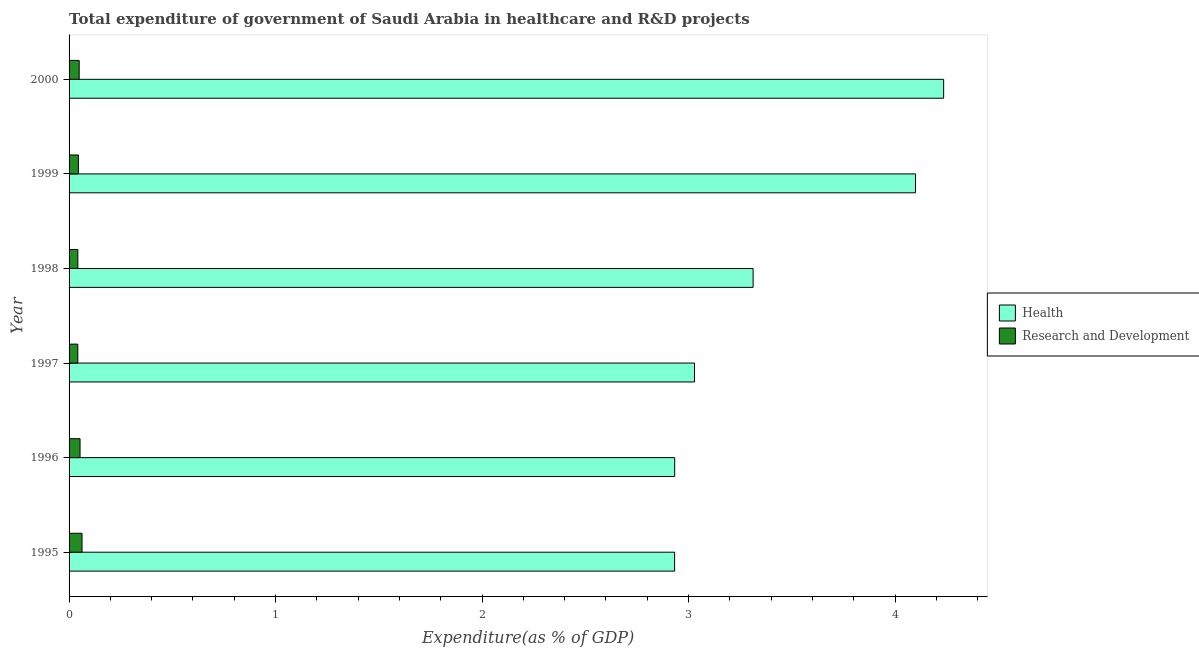How many different coloured bars are there?
Give a very brief answer. 2. How many groups of bars are there?
Give a very brief answer. 6. Are the number of bars per tick equal to the number of legend labels?
Keep it short and to the point. Yes. Are the number of bars on each tick of the Y-axis equal?
Ensure brevity in your answer.  Yes. What is the label of the 3rd group of bars from the top?
Offer a very short reply. 1998. In how many cases, is the number of bars for a given year not equal to the number of legend labels?
Provide a short and direct response. 0. What is the expenditure in r&d in 1998?
Keep it short and to the point. 0.04. Across all years, what is the maximum expenditure in healthcare?
Your response must be concise. 4.24. Across all years, what is the minimum expenditure in healthcare?
Offer a very short reply. 2.93. In which year was the expenditure in r&d maximum?
Your response must be concise. 1995. In which year was the expenditure in healthcare minimum?
Ensure brevity in your answer.  1995. What is the total expenditure in r&d in the graph?
Keep it short and to the point. 0.29. What is the difference between the expenditure in r&d in 1997 and that in 2000?
Provide a succinct answer. -0.01. What is the difference between the expenditure in r&d in 2000 and the expenditure in healthcare in 1997?
Keep it short and to the point. -2.98. What is the average expenditure in healthcare per year?
Keep it short and to the point. 3.42. In the year 1998, what is the difference between the expenditure in healthcare and expenditure in r&d?
Give a very brief answer. 3.27. What is the ratio of the expenditure in healthcare in 1995 to that in 1996?
Your answer should be very brief. 1. Is the difference between the expenditure in healthcare in 1995 and 2000 greater than the difference between the expenditure in r&d in 1995 and 2000?
Your answer should be very brief. No. What is the difference between the highest and the second highest expenditure in healthcare?
Ensure brevity in your answer.  0.14. In how many years, is the expenditure in healthcare greater than the average expenditure in healthcare taken over all years?
Provide a succinct answer. 2. What does the 1st bar from the top in 1996 represents?
Provide a short and direct response. Research and Development. What does the 1st bar from the bottom in 1996 represents?
Provide a short and direct response. Health. How many bars are there?
Keep it short and to the point. 12. Are all the bars in the graph horizontal?
Provide a succinct answer. Yes. Where does the legend appear in the graph?
Offer a terse response. Center right. How are the legend labels stacked?
Offer a very short reply. Vertical. What is the title of the graph?
Your answer should be compact. Total expenditure of government of Saudi Arabia in healthcare and R&D projects. Does "Under-5(female)" appear as one of the legend labels in the graph?
Give a very brief answer. No. What is the label or title of the X-axis?
Give a very brief answer. Expenditure(as % of GDP). What is the label or title of the Y-axis?
Ensure brevity in your answer.  Year. What is the Expenditure(as % of GDP) of Health in 1995?
Your answer should be compact. 2.93. What is the Expenditure(as % of GDP) of Research and Development in 1995?
Provide a succinct answer. 0.06. What is the Expenditure(as % of GDP) in Health in 1996?
Your answer should be very brief. 2.93. What is the Expenditure(as % of GDP) in Research and Development in 1996?
Provide a succinct answer. 0.05. What is the Expenditure(as % of GDP) in Health in 1997?
Your response must be concise. 3.03. What is the Expenditure(as % of GDP) of Research and Development in 1997?
Make the answer very short. 0.04. What is the Expenditure(as % of GDP) of Health in 1998?
Your response must be concise. 3.31. What is the Expenditure(as % of GDP) in Research and Development in 1998?
Offer a terse response. 0.04. What is the Expenditure(as % of GDP) in Health in 1999?
Your response must be concise. 4.1. What is the Expenditure(as % of GDP) in Research and Development in 1999?
Ensure brevity in your answer.  0.05. What is the Expenditure(as % of GDP) in Health in 2000?
Your answer should be very brief. 4.24. What is the Expenditure(as % of GDP) of Research and Development in 2000?
Ensure brevity in your answer.  0.05. Across all years, what is the maximum Expenditure(as % of GDP) of Health?
Provide a succinct answer. 4.24. Across all years, what is the maximum Expenditure(as % of GDP) in Research and Development?
Give a very brief answer. 0.06. Across all years, what is the minimum Expenditure(as % of GDP) of Health?
Provide a succinct answer. 2.93. Across all years, what is the minimum Expenditure(as % of GDP) of Research and Development?
Your response must be concise. 0.04. What is the total Expenditure(as % of GDP) in Health in the graph?
Make the answer very short. 20.54. What is the total Expenditure(as % of GDP) of Research and Development in the graph?
Offer a terse response. 0.29. What is the difference between the Expenditure(as % of GDP) in Health in 1995 and that in 1996?
Ensure brevity in your answer.  -0. What is the difference between the Expenditure(as % of GDP) of Research and Development in 1995 and that in 1996?
Your response must be concise. 0.01. What is the difference between the Expenditure(as % of GDP) of Health in 1995 and that in 1997?
Your answer should be very brief. -0.1. What is the difference between the Expenditure(as % of GDP) in Research and Development in 1995 and that in 1997?
Give a very brief answer. 0.02. What is the difference between the Expenditure(as % of GDP) in Health in 1995 and that in 1998?
Your response must be concise. -0.38. What is the difference between the Expenditure(as % of GDP) of Research and Development in 1995 and that in 1998?
Make the answer very short. 0.02. What is the difference between the Expenditure(as % of GDP) of Health in 1995 and that in 1999?
Provide a succinct answer. -1.17. What is the difference between the Expenditure(as % of GDP) in Research and Development in 1995 and that in 1999?
Make the answer very short. 0.02. What is the difference between the Expenditure(as % of GDP) in Health in 1995 and that in 2000?
Offer a terse response. -1.3. What is the difference between the Expenditure(as % of GDP) of Research and Development in 1995 and that in 2000?
Make the answer very short. 0.01. What is the difference between the Expenditure(as % of GDP) of Health in 1996 and that in 1997?
Provide a short and direct response. -0.1. What is the difference between the Expenditure(as % of GDP) of Research and Development in 1996 and that in 1997?
Offer a very short reply. 0.01. What is the difference between the Expenditure(as % of GDP) in Health in 1996 and that in 1998?
Your answer should be very brief. -0.38. What is the difference between the Expenditure(as % of GDP) in Research and Development in 1996 and that in 1998?
Give a very brief answer. 0.01. What is the difference between the Expenditure(as % of GDP) in Health in 1996 and that in 1999?
Provide a short and direct response. -1.17. What is the difference between the Expenditure(as % of GDP) of Research and Development in 1996 and that in 1999?
Your answer should be compact. 0.01. What is the difference between the Expenditure(as % of GDP) of Health in 1996 and that in 2000?
Your response must be concise. -1.3. What is the difference between the Expenditure(as % of GDP) in Research and Development in 1996 and that in 2000?
Ensure brevity in your answer.  0. What is the difference between the Expenditure(as % of GDP) of Health in 1997 and that in 1998?
Provide a succinct answer. -0.28. What is the difference between the Expenditure(as % of GDP) of Research and Development in 1997 and that in 1998?
Your response must be concise. -0. What is the difference between the Expenditure(as % of GDP) of Health in 1997 and that in 1999?
Give a very brief answer. -1.07. What is the difference between the Expenditure(as % of GDP) of Research and Development in 1997 and that in 1999?
Provide a short and direct response. -0. What is the difference between the Expenditure(as % of GDP) of Health in 1997 and that in 2000?
Provide a short and direct response. -1.21. What is the difference between the Expenditure(as % of GDP) in Research and Development in 1997 and that in 2000?
Your response must be concise. -0.01. What is the difference between the Expenditure(as % of GDP) in Health in 1998 and that in 1999?
Your answer should be very brief. -0.79. What is the difference between the Expenditure(as % of GDP) in Research and Development in 1998 and that in 1999?
Provide a short and direct response. -0. What is the difference between the Expenditure(as % of GDP) in Health in 1998 and that in 2000?
Ensure brevity in your answer.  -0.92. What is the difference between the Expenditure(as % of GDP) of Research and Development in 1998 and that in 2000?
Provide a short and direct response. -0.01. What is the difference between the Expenditure(as % of GDP) in Health in 1999 and that in 2000?
Offer a terse response. -0.14. What is the difference between the Expenditure(as % of GDP) of Research and Development in 1999 and that in 2000?
Keep it short and to the point. -0. What is the difference between the Expenditure(as % of GDP) of Health in 1995 and the Expenditure(as % of GDP) of Research and Development in 1996?
Ensure brevity in your answer.  2.88. What is the difference between the Expenditure(as % of GDP) in Health in 1995 and the Expenditure(as % of GDP) in Research and Development in 1997?
Your answer should be very brief. 2.89. What is the difference between the Expenditure(as % of GDP) of Health in 1995 and the Expenditure(as % of GDP) of Research and Development in 1998?
Make the answer very short. 2.89. What is the difference between the Expenditure(as % of GDP) of Health in 1995 and the Expenditure(as % of GDP) of Research and Development in 1999?
Your response must be concise. 2.89. What is the difference between the Expenditure(as % of GDP) in Health in 1995 and the Expenditure(as % of GDP) in Research and Development in 2000?
Your answer should be very brief. 2.88. What is the difference between the Expenditure(as % of GDP) in Health in 1996 and the Expenditure(as % of GDP) in Research and Development in 1997?
Provide a succinct answer. 2.89. What is the difference between the Expenditure(as % of GDP) in Health in 1996 and the Expenditure(as % of GDP) in Research and Development in 1998?
Offer a terse response. 2.89. What is the difference between the Expenditure(as % of GDP) in Health in 1996 and the Expenditure(as % of GDP) in Research and Development in 1999?
Provide a succinct answer. 2.89. What is the difference between the Expenditure(as % of GDP) of Health in 1996 and the Expenditure(as % of GDP) of Research and Development in 2000?
Provide a succinct answer. 2.88. What is the difference between the Expenditure(as % of GDP) in Health in 1997 and the Expenditure(as % of GDP) in Research and Development in 1998?
Give a very brief answer. 2.99. What is the difference between the Expenditure(as % of GDP) in Health in 1997 and the Expenditure(as % of GDP) in Research and Development in 1999?
Your response must be concise. 2.98. What is the difference between the Expenditure(as % of GDP) in Health in 1997 and the Expenditure(as % of GDP) in Research and Development in 2000?
Your response must be concise. 2.98. What is the difference between the Expenditure(as % of GDP) in Health in 1998 and the Expenditure(as % of GDP) in Research and Development in 1999?
Ensure brevity in your answer.  3.27. What is the difference between the Expenditure(as % of GDP) in Health in 1998 and the Expenditure(as % of GDP) in Research and Development in 2000?
Make the answer very short. 3.26. What is the difference between the Expenditure(as % of GDP) in Health in 1999 and the Expenditure(as % of GDP) in Research and Development in 2000?
Make the answer very short. 4.05. What is the average Expenditure(as % of GDP) of Health per year?
Provide a short and direct response. 3.42. What is the average Expenditure(as % of GDP) of Research and Development per year?
Keep it short and to the point. 0.05. In the year 1995, what is the difference between the Expenditure(as % of GDP) of Health and Expenditure(as % of GDP) of Research and Development?
Offer a very short reply. 2.87. In the year 1996, what is the difference between the Expenditure(as % of GDP) of Health and Expenditure(as % of GDP) of Research and Development?
Your answer should be compact. 2.88. In the year 1997, what is the difference between the Expenditure(as % of GDP) of Health and Expenditure(as % of GDP) of Research and Development?
Make the answer very short. 2.99. In the year 1998, what is the difference between the Expenditure(as % of GDP) of Health and Expenditure(as % of GDP) of Research and Development?
Provide a short and direct response. 3.27. In the year 1999, what is the difference between the Expenditure(as % of GDP) in Health and Expenditure(as % of GDP) in Research and Development?
Make the answer very short. 4.05. In the year 2000, what is the difference between the Expenditure(as % of GDP) of Health and Expenditure(as % of GDP) of Research and Development?
Your answer should be very brief. 4.19. What is the ratio of the Expenditure(as % of GDP) in Research and Development in 1995 to that in 1996?
Ensure brevity in your answer.  1.18. What is the ratio of the Expenditure(as % of GDP) in Health in 1995 to that in 1997?
Your answer should be compact. 0.97. What is the ratio of the Expenditure(as % of GDP) in Research and Development in 1995 to that in 1997?
Ensure brevity in your answer.  1.48. What is the ratio of the Expenditure(as % of GDP) in Health in 1995 to that in 1998?
Your answer should be compact. 0.89. What is the ratio of the Expenditure(as % of GDP) of Research and Development in 1995 to that in 1998?
Offer a terse response. 1.48. What is the ratio of the Expenditure(as % of GDP) of Health in 1995 to that in 1999?
Provide a succinct answer. 0.72. What is the ratio of the Expenditure(as % of GDP) of Research and Development in 1995 to that in 1999?
Make the answer very short. 1.39. What is the ratio of the Expenditure(as % of GDP) of Health in 1995 to that in 2000?
Your answer should be compact. 0.69. What is the ratio of the Expenditure(as % of GDP) in Research and Development in 1995 to that in 2000?
Provide a short and direct response. 1.28. What is the ratio of the Expenditure(as % of GDP) in Health in 1996 to that in 1997?
Provide a short and direct response. 0.97. What is the ratio of the Expenditure(as % of GDP) of Research and Development in 1996 to that in 1997?
Keep it short and to the point. 1.26. What is the ratio of the Expenditure(as % of GDP) of Health in 1996 to that in 1998?
Offer a terse response. 0.89. What is the ratio of the Expenditure(as % of GDP) of Research and Development in 1996 to that in 1998?
Your answer should be very brief. 1.25. What is the ratio of the Expenditure(as % of GDP) of Health in 1996 to that in 1999?
Offer a terse response. 0.72. What is the ratio of the Expenditure(as % of GDP) in Research and Development in 1996 to that in 1999?
Make the answer very short. 1.18. What is the ratio of the Expenditure(as % of GDP) in Health in 1996 to that in 2000?
Offer a very short reply. 0.69. What is the ratio of the Expenditure(as % of GDP) of Research and Development in 1996 to that in 2000?
Offer a terse response. 1.08. What is the ratio of the Expenditure(as % of GDP) in Health in 1997 to that in 1998?
Ensure brevity in your answer.  0.91. What is the ratio of the Expenditure(as % of GDP) of Research and Development in 1997 to that in 1998?
Ensure brevity in your answer.  1. What is the ratio of the Expenditure(as % of GDP) of Health in 1997 to that in 1999?
Your response must be concise. 0.74. What is the ratio of the Expenditure(as % of GDP) of Research and Development in 1997 to that in 1999?
Offer a terse response. 0.94. What is the ratio of the Expenditure(as % of GDP) of Health in 1997 to that in 2000?
Keep it short and to the point. 0.72. What is the ratio of the Expenditure(as % of GDP) in Research and Development in 1997 to that in 2000?
Provide a short and direct response. 0.86. What is the ratio of the Expenditure(as % of GDP) of Health in 1998 to that in 1999?
Give a very brief answer. 0.81. What is the ratio of the Expenditure(as % of GDP) in Research and Development in 1998 to that in 1999?
Give a very brief answer. 0.94. What is the ratio of the Expenditure(as % of GDP) in Health in 1998 to that in 2000?
Offer a very short reply. 0.78. What is the ratio of the Expenditure(as % of GDP) in Research and Development in 1998 to that in 2000?
Your answer should be very brief. 0.87. What is the ratio of the Expenditure(as % of GDP) in Health in 1999 to that in 2000?
Your answer should be compact. 0.97. What is the ratio of the Expenditure(as % of GDP) in Research and Development in 1999 to that in 2000?
Your response must be concise. 0.92. What is the difference between the highest and the second highest Expenditure(as % of GDP) of Health?
Provide a succinct answer. 0.14. What is the difference between the highest and the second highest Expenditure(as % of GDP) in Research and Development?
Keep it short and to the point. 0.01. What is the difference between the highest and the lowest Expenditure(as % of GDP) of Health?
Your answer should be compact. 1.3. What is the difference between the highest and the lowest Expenditure(as % of GDP) of Research and Development?
Offer a terse response. 0.02. 